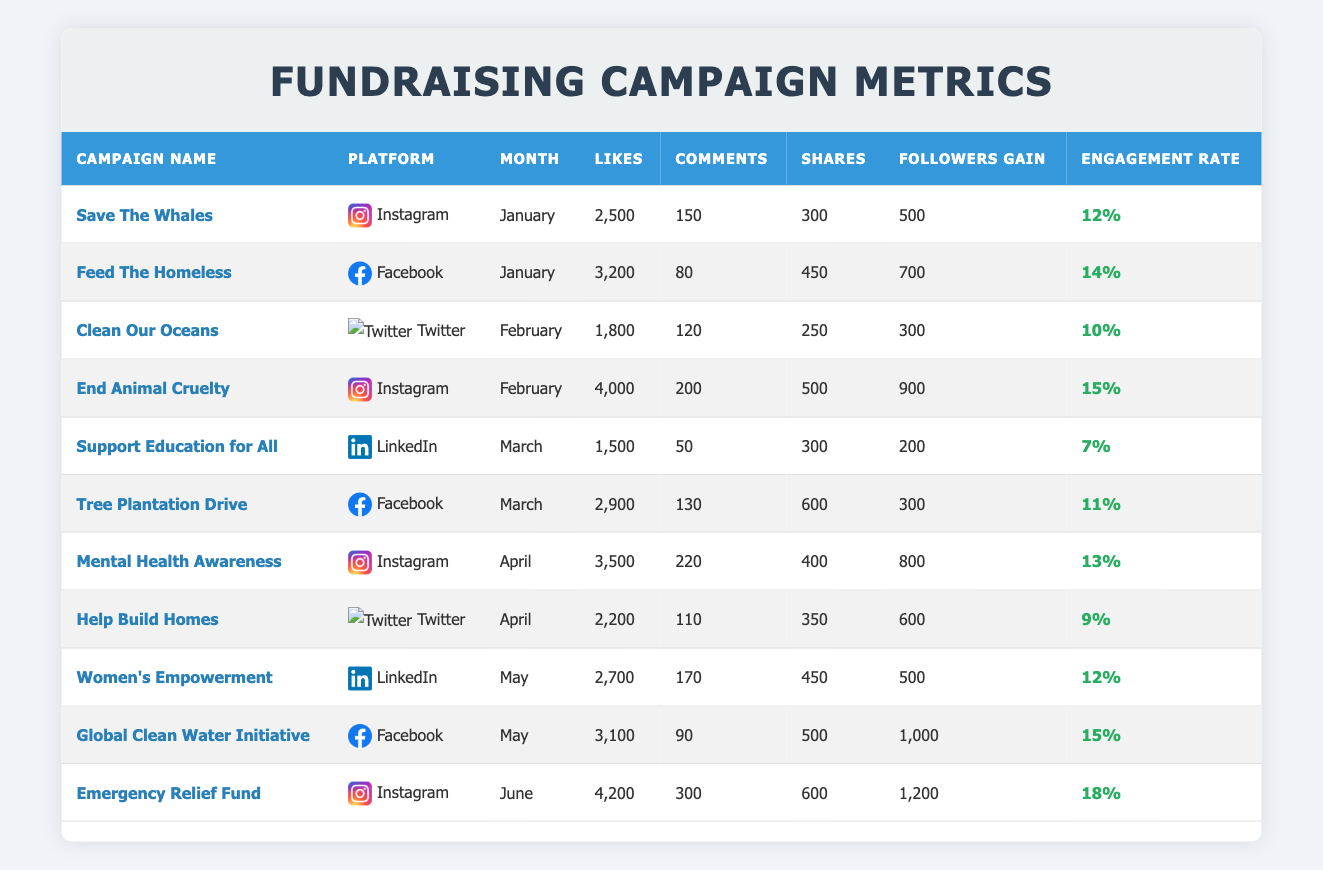What is the engagement rate for the "Global Clean Water Initiative"? The table shows the details for the "Global Clean Water Initiative" under the month of May with a recorded engagement rate of 15%. Therefore, the value can be directly retrieved from the table.
Answer: 15% Which campaign had the highest followers gain in June? In June, the "Emergency Relief Fund" campaign registered the highest followers gain at 1,200, compared to other campaigns in that month. This information can be seen clearly in the respective row of the table.
Answer: 1,200 What is the average engagement rate for campaigns on Instagram? The engagement rates for Instagram campaigns are 12%, 15%, 13%, and 18%. To find the average, we sum these values: 12 + 15 + 13 + 18 = 58. There are 4 campaigns, so the average is 58/4 = 14.5%.
Answer: 14.5% Did "Support Education for All" campaign have more likes than the "Tree Plantation Drive" campaign? The "Support Education for All" campaign has 1,500 likes, while "Tree Plantation Drive" has 2,900 likes. Comparing these two values shows that "Support Education for All" had fewer likes.
Answer: No Which month had the most campaigns listed, and how many campaigns were there? The table lists campaigns for the months of January, February, March, April, May, and June. In February, there are 2 campaigns ("Clean Our Oceans" and "End Animal Cruelty"), while other months have either 1 campaign or 2 as well. Counting them leads to the conclusion that every month had at least one campaign, but February had a total of 2 listed in this table leading to the conclusion of the most occurring month.
Answer: February, 2 campaigns What is the total number of likes received by all campaigns on Facebook? The campaigns on Facebook in the table are "Feed The Homeless," "Tree Plantation Drive," and "Global Clean Water Initiative," which received 3,200, 2,900, and 3,100 likes, respectively. To find the total number of likes, we add these values: 3,200 + 2,900 + 3,100 = 9,200.
Answer: 9,200 Which campaign had the least number of comments, and how many were there? By reviewing the comments for each campaign, we find that "Support Education for All" had the least with 50 comments. Comparing against other campaigns, this value stands out as the minimum.
Answer: 50 How many shares did the "Women's Empowerment" campaign receive compared to the "Mental Health Awareness" campaign? The "Women's Empowerment" campaign received 450 shares while "Mental Health Awareness" received 400 shares. By comparing these values, it's evident that "Women's Empowerment" had more shares.
Answer: More shares for "Women's Empowerment" (450 vs 400) 